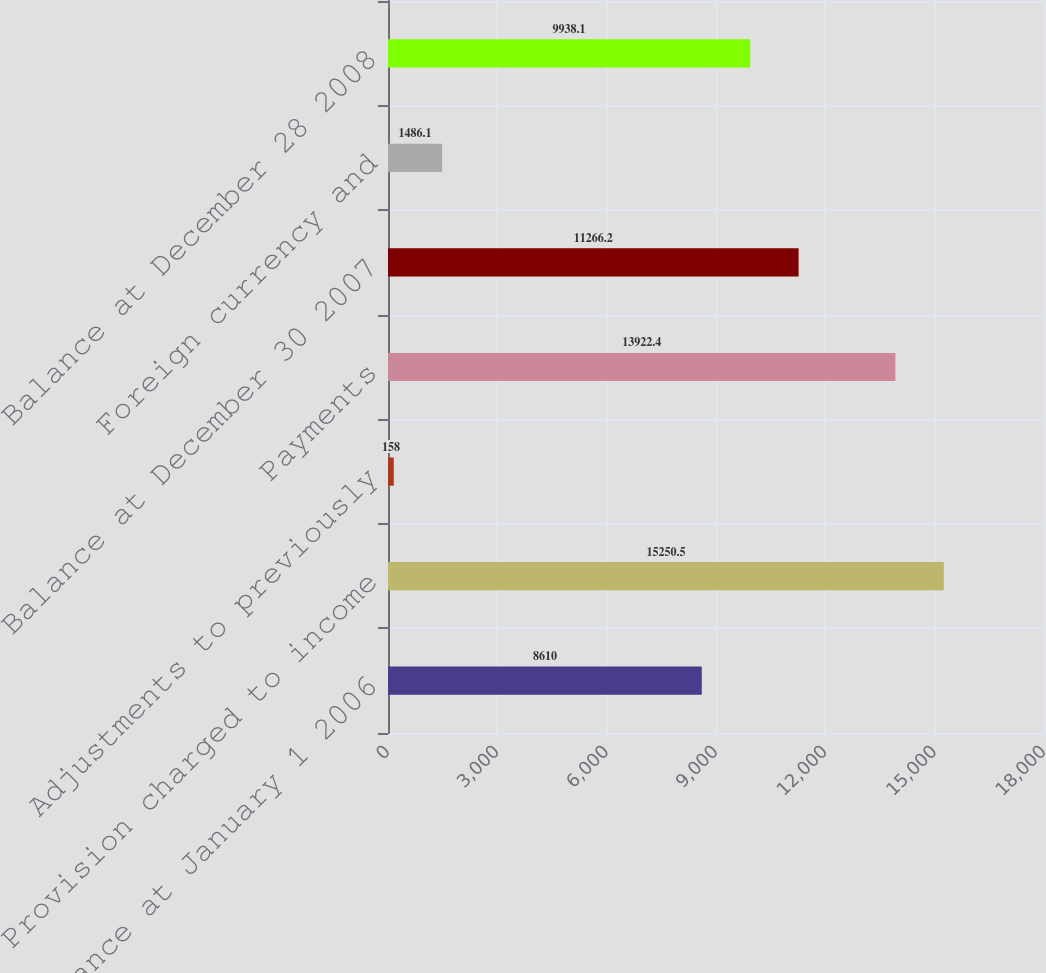<chart> <loc_0><loc_0><loc_500><loc_500><bar_chart><fcel>Balance at January 1 2006<fcel>Provision charged to income<fcel>Adjustments to previously<fcel>Payments<fcel>Balance at December 30 2007<fcel>Foreign currency and<fcel>Balance at December 28 2008<nl><fcel>8610<fcel>15250.5<fcel>158<fcel>13922.4<fcel>11266.2<fcel>1486.1<fcel>9938.1<nl></chart> 